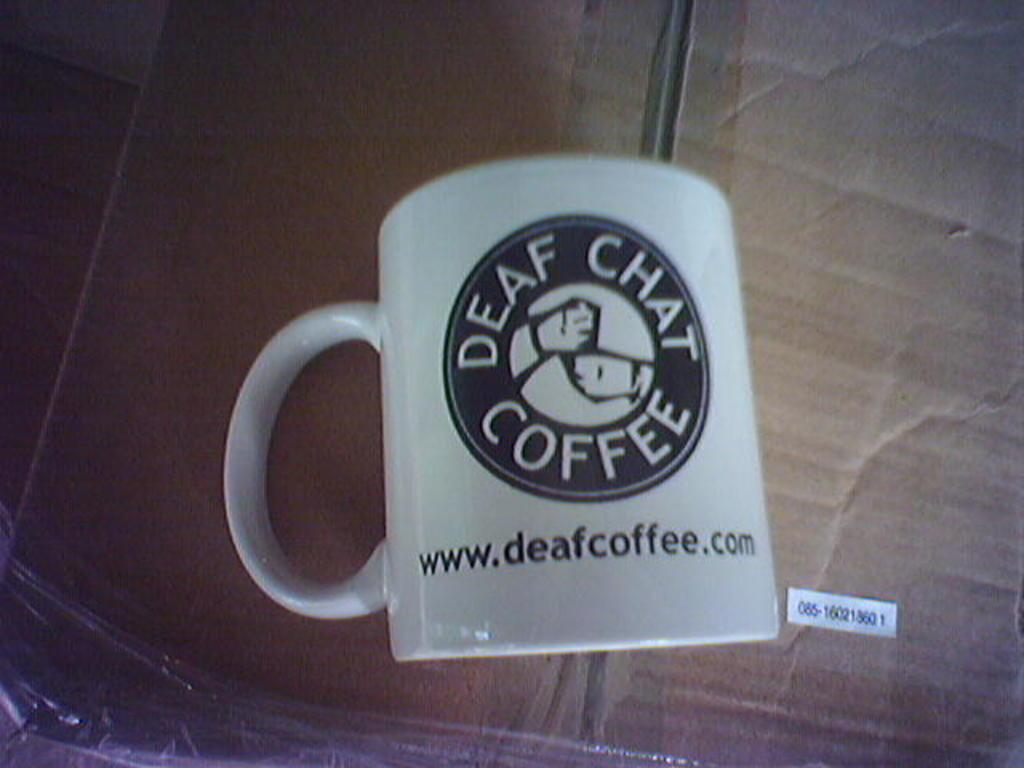<image>
Render a clear and concise summary of the photo. a white mug with the words Deaf Chat Coffee 